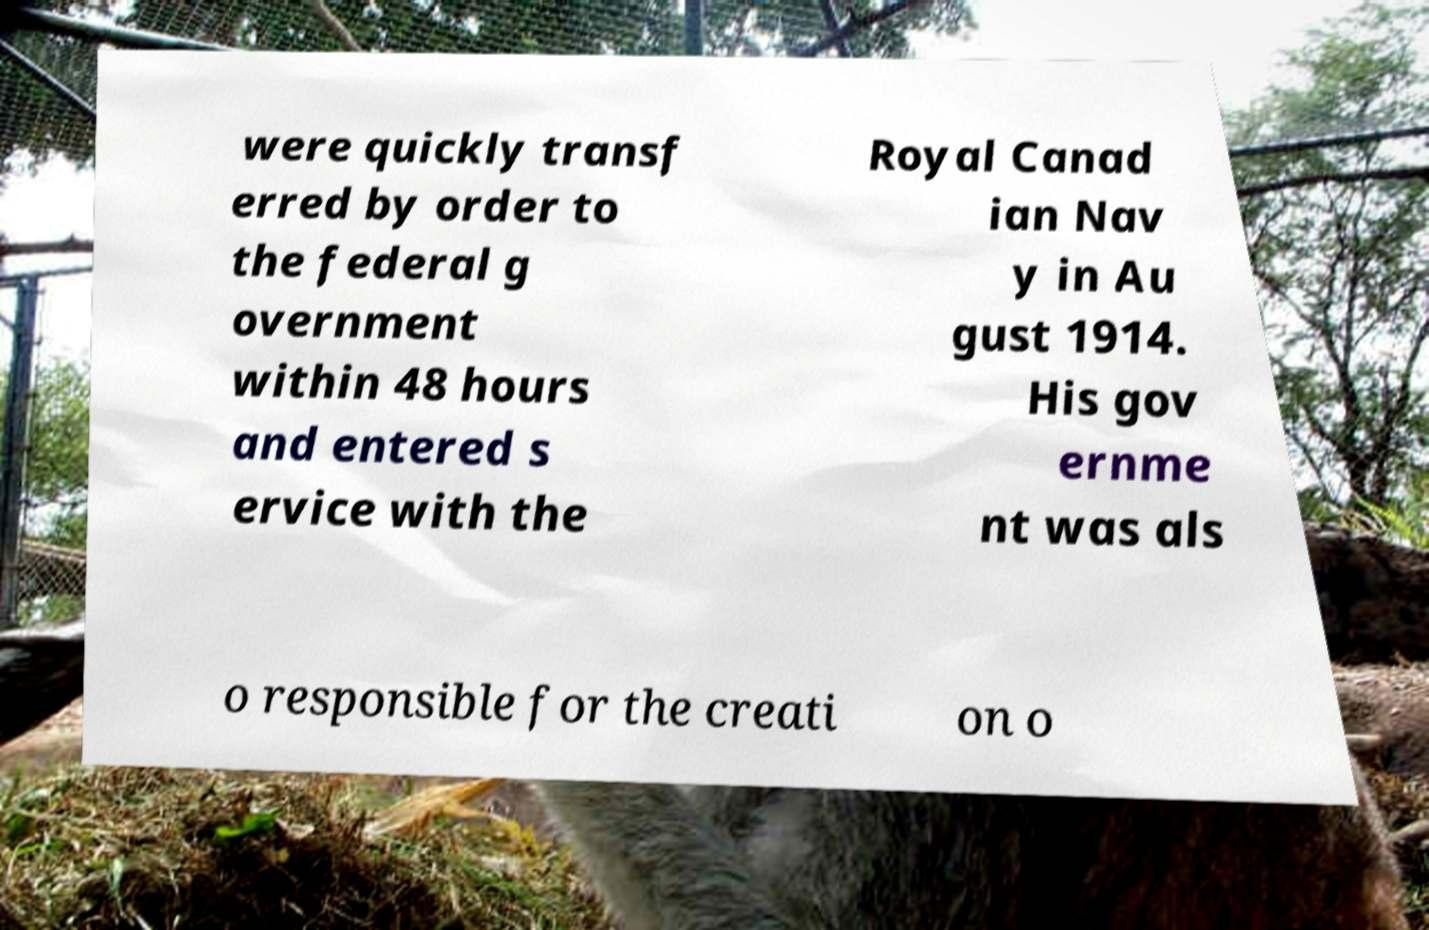Please identify and transcribe the text found in this image. were quickly transf erred by order to the federal g overnment within 48 hours and entered s ervice with the Royal Canad ian Nav y in Au gust 1914. His gov ernme nt was als o responsible for the creati on o 